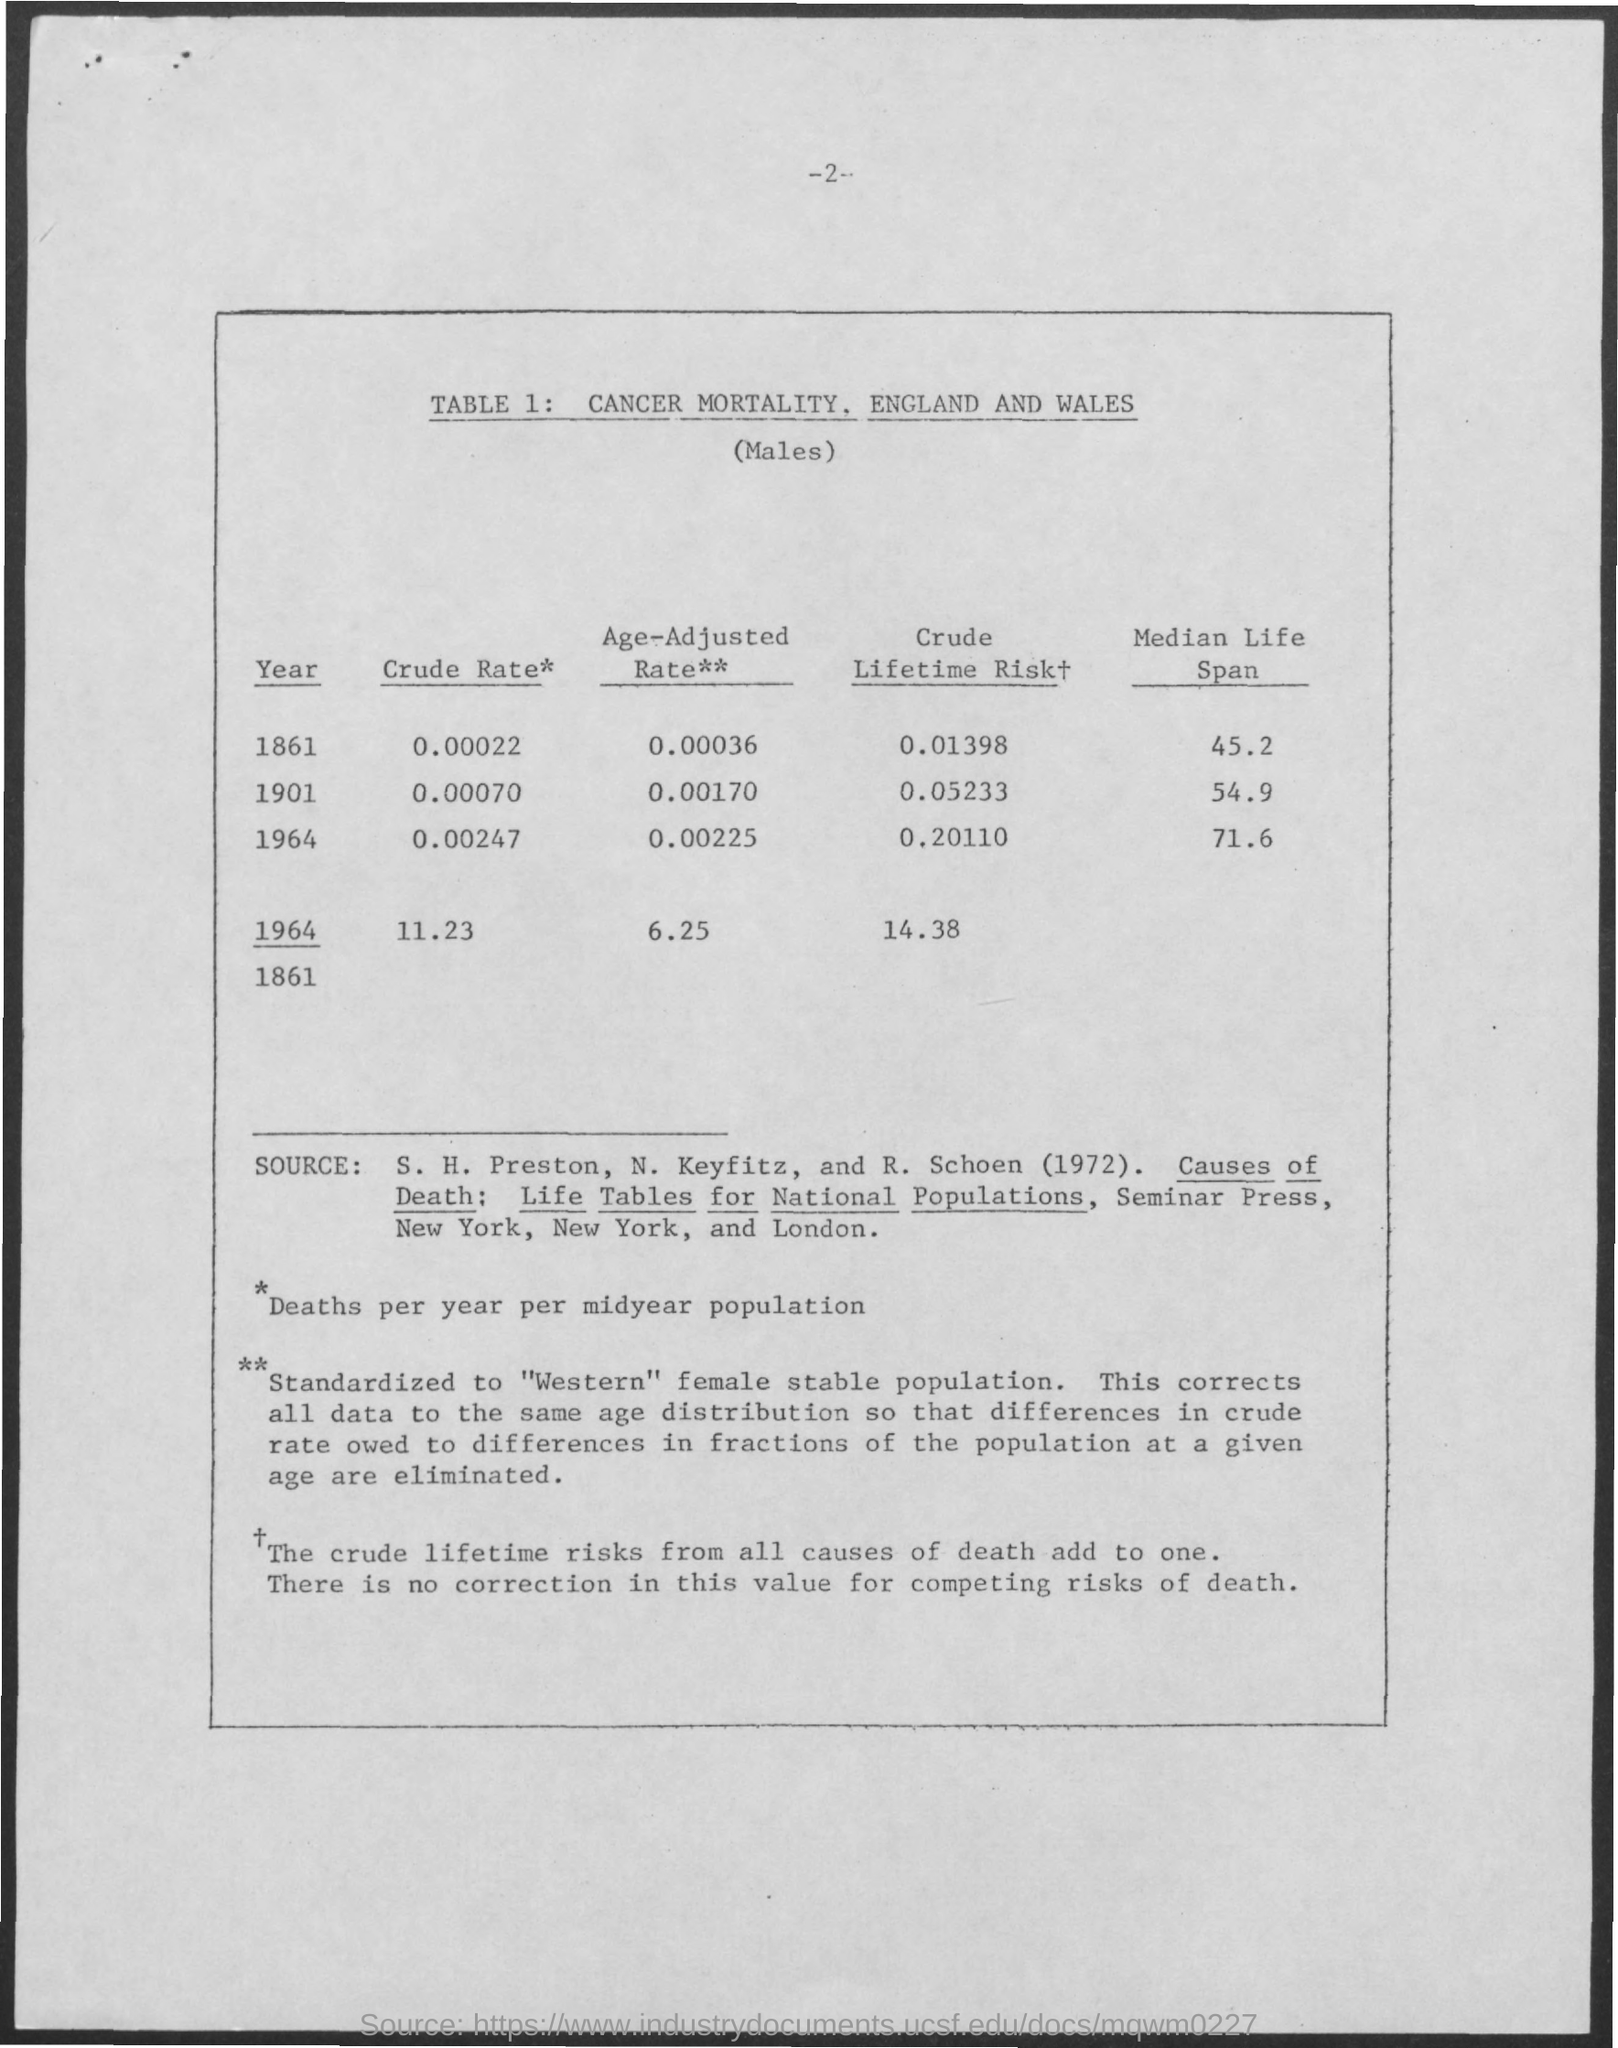Identify some key points in this picture. The median life span in the year 1964 was 71.6 years. In the year 1861, the age-adjusted rate was 0.00036... The age-adjusted rate in the year 1901 was 0.00170... The median life span in the year 1901 was 54.9 years. The table number is 1 and counting upwards from there. 